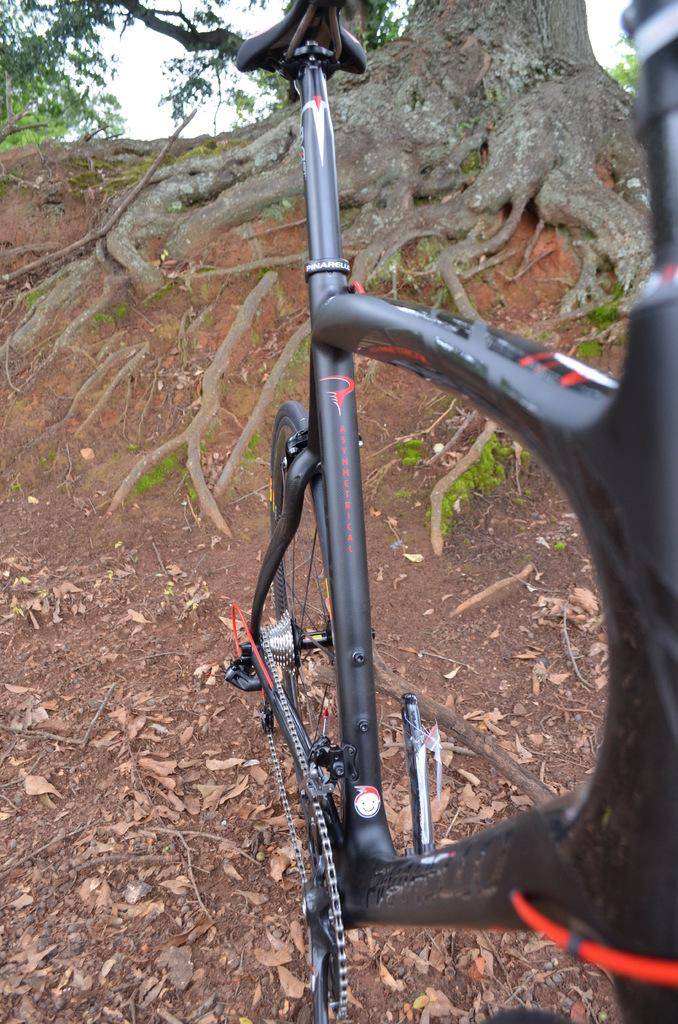What object is on the ground in the image? There is a bicycle on the ground. What can be seen in the background of the image? There are trees and the sky visible in the background of the image. Are there any specific features of the trees in the background? Yes, there are roots of a tree in the background of the image. Where is the shop located in the image? There is no shop present in the image. Is there a rifle visible in the image? There is no rifle present in the image. 